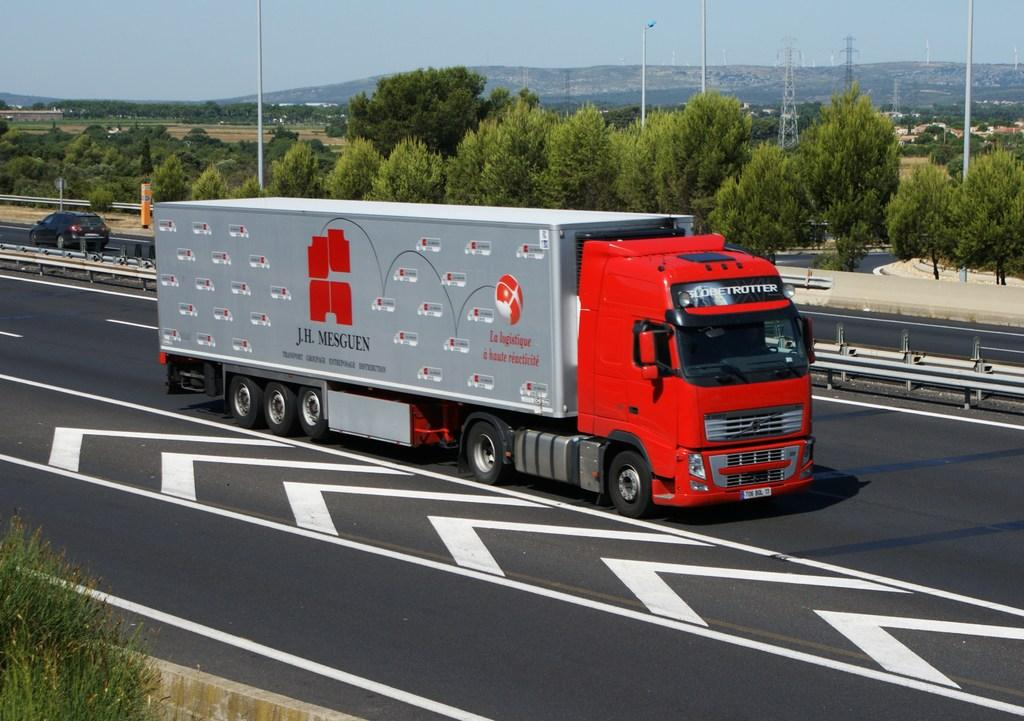What can be seen on the road in the image? There are vehicles on the road in the image. What type of natural elements are visible in the image? There are trees and mountains visible in the image. What structures can be seen in the image? There are poles and towers in the image. What part of the natural environment is visible in the image? The sky is visible in the image. Where is the queen's nest located in the image? There is no queen or nest present in the image. What level of difficulty can be seen in the image? The image does not depict a level of difficulty; it shows vehicles, trees, poles, towers, mountains, and the sky. 